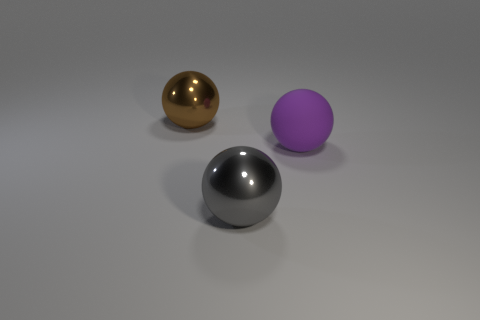Is there any other thing that has the same size as the purple object?
Ensure brevity in your answer.  Yes. What is the material of the other big brown thing that is the same shape as the rubber thing?
Your response must be concise. Metal. There is a large shiny thing that is behind the large metallic sphere in front of the large metal object behind the big purple rubber thing; what is its color?
Give a very brief answer. Brown. How many objects are big purple objects or metal things?
Keep it short and to the point. 3. What number of other things have the same shape as the brown thing?
Provide a succinct answer. 2. Is the big brown object made of the same material as the thing that is in front of the large purple ball?
Make the answer very short. Yes. The brown ball that is made of the same material as the big gray ball is what size?
Provide a succinct answer. Large. There is a metal ball in front of the big rubber ball; what size is it?
Offer a very short reply. Large. How many metallic spheres are the same size as the purple rubber ball?
Ensure brevity in your answer.  2. Are there any other spheres that have the same color as the large rubber ball?
Offer a terse response. No. 